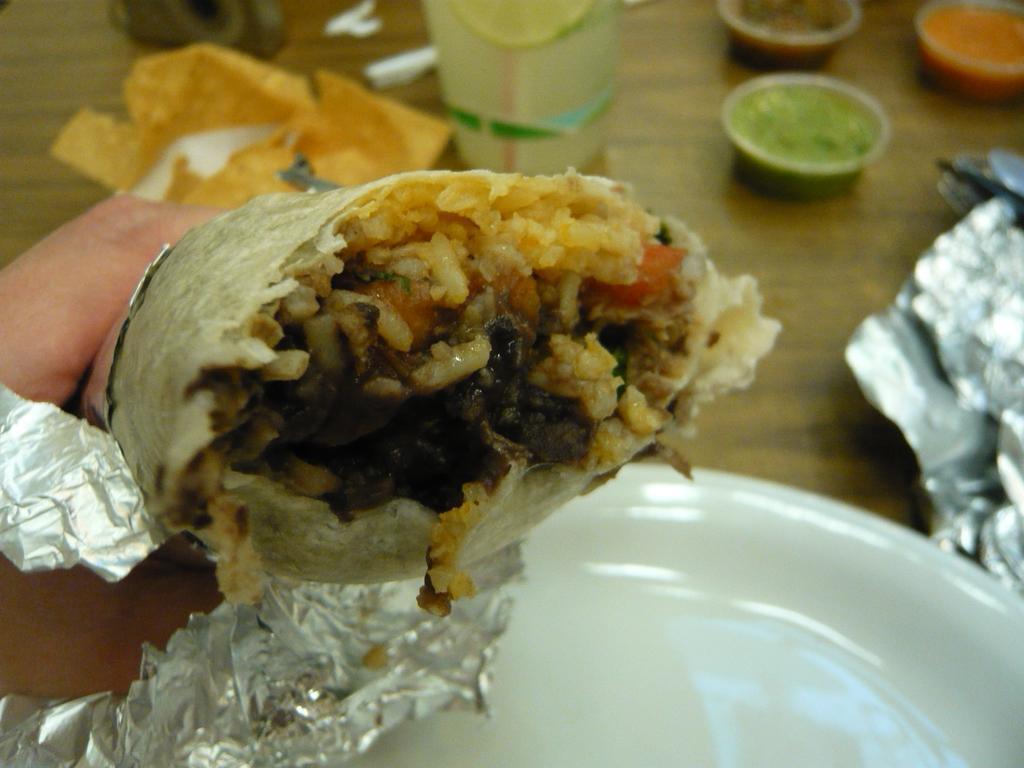Could you give a brief overview of what you see in this image? In this picture we can see a chicken wrap in the front. Beside there is a white plate, aluminium foil, green and red sauce is placed on the table top. 